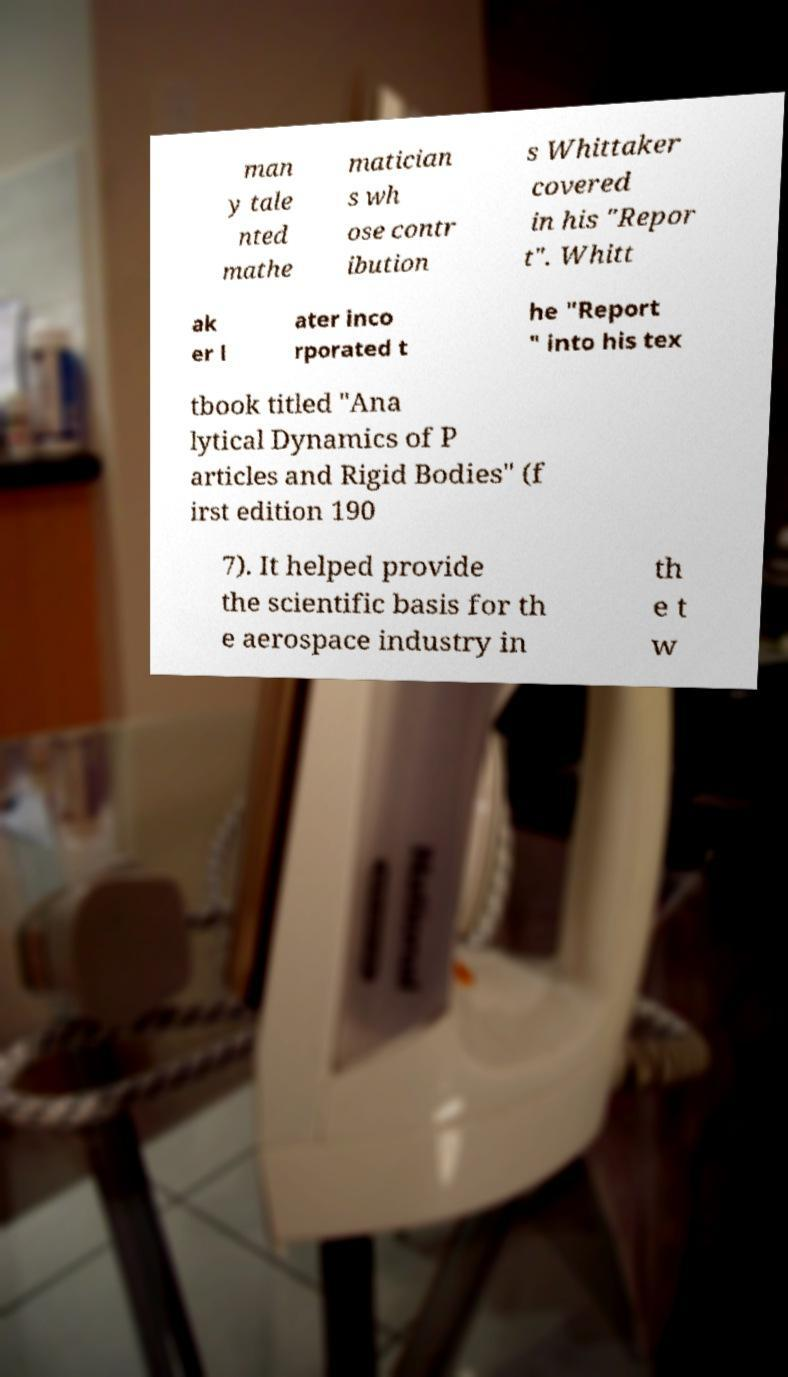For documentation purposes, I need the text within this image transcribed. Could you provide that? man y tale nted mathe matician s wh ose contr ibution s Whittaker covered in his "Repor t". Whitt ak er l ater inco rporated t he "Report " into his tex tbook titled "Ana lytical Dynamics of P articles and Rigid Bodies" (f irst edition 190 7). It helped provide the scientific basis for th e aerospace industry in th e t w 